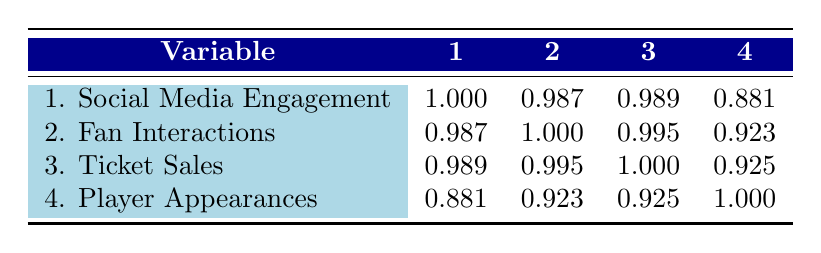What is the correlation coefficient between social media engagement and ticket sales? The correlation coefficient between social media engagement (variable 1) and ticket sales (variable 3) is 0.989, as shown in the table.
Answer: 0.989 What is the highest correlation value in the table? The highest correlation value is 1.000, indicating a perfect correlation between ticket sales and fan interactions (variables 2 and 3).
Answer: 1.000 Are ticket sales and player appearances correlated? Yes, the correlation between ticket sales (variable 3) and player appearances (variable 4) is 0.925, indicating a strong positive relationship.
Answer: Yes What is the average social media engagement across all events? The average social media engagement can be calculated as follows: (850000 + 600000 + 950000 + 500000 + 300000 + 400000 + 700000) / 7 = 607142.86.
Answer: 607142.86 Which two variables have the lowest correlation? The correlation coefficient between social media engagement (variable 1) and player appearances (variable 4) is 0.881, the lowest correlation in the table.
Answer: 0.881 Does higher fan interaction always lead to higher ticket sales? No, while there is a strong correlation between fan interactions (variable 2) and ticket sales (variable 3), it does not imply causation; other factors may influence ticket sales.
Answer: No What is the difference in correlation between fan interactions and social media engagement compared to ticket sales and player appearances? The correlation between fan interactions and social media engagement is 0.987, while between ticket sales and player appearances, it's 0.925. The difference is 0.987 - 0.925 = 0.062.
Answer: 0.062 What percentage of total interactions at the US Open 2021 resulted in ticket sales? The total interactions at the US Open 2021 can be derived by adding social media engagement (850000) and fan interactions (120000), which gives 970000; then, ticket sales were 72000, resulting in (72000 / 970000) * 100 ≈ 7.22%.
Answer: 7.22% Are social media engagement and fan interactions negatively correlated? No, social media engagement and fan interactions have a correlation of 0.987, indicating a strong positive correlation, meaning they tend to increase together.
Answer: No 